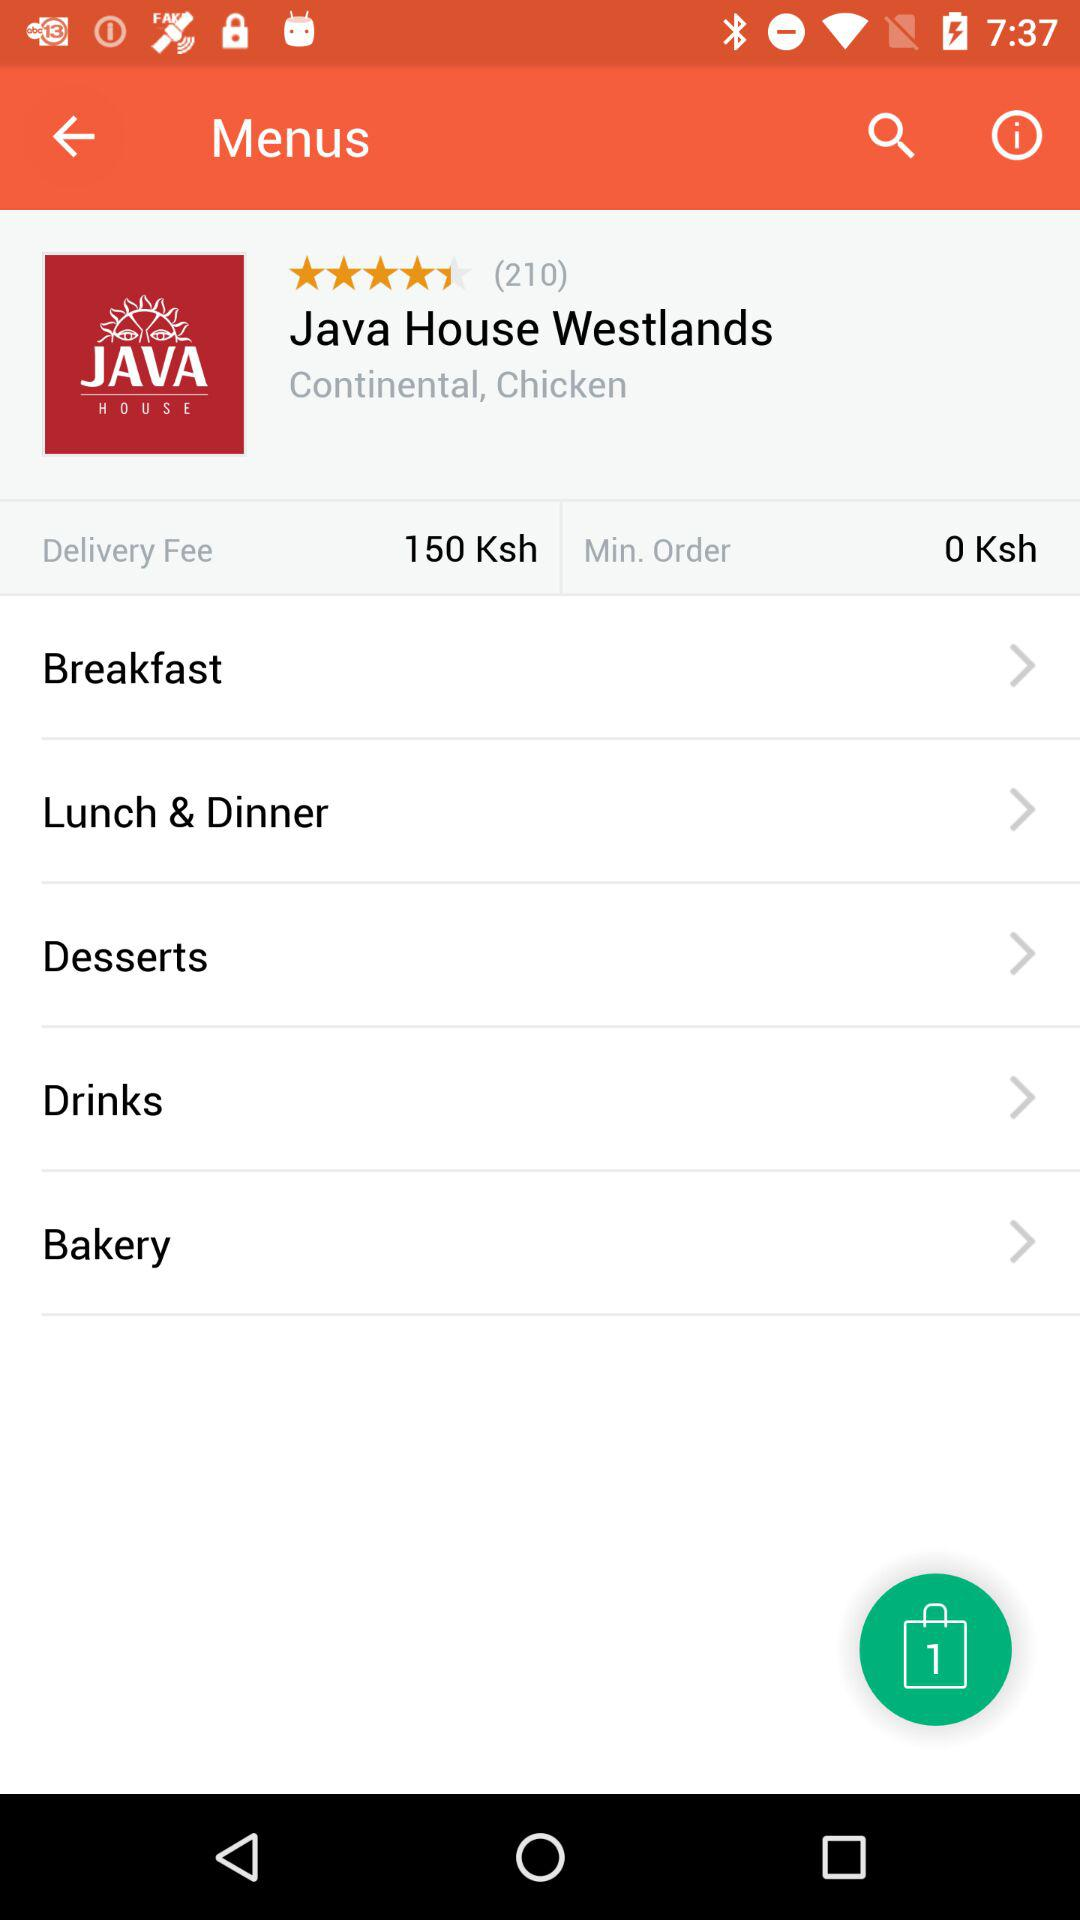How much is the delivery fee? The delivery fee is "150 Ksh". 